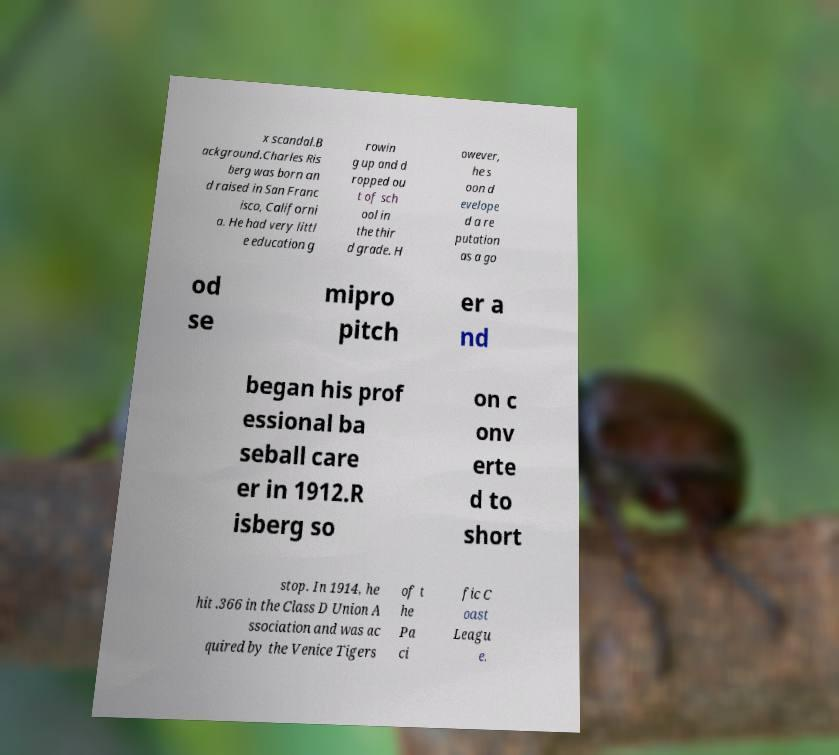Can you read and provide the text displayed in the image?This photo seems to have some interesting text. Can you extract and type it out for me? x scandal.B ackground.Charles Ris berg was born an d raised in San Franc isco, Californi a. He had very littl e education g rowin g up and d ropped ou t of sch ool in the thir d grade. H owever, he s oon d evelope d a re putation as a go od se mipro pitch er a nd began his prof essional ba seball care er in 1912.R isberg so on c onv erte d to short stop. In 1914, he hit .366 in the Class D Union A ssociation and was ac quired by the Venice Tigers of t he Pa ci fic C oast Leagu e. 